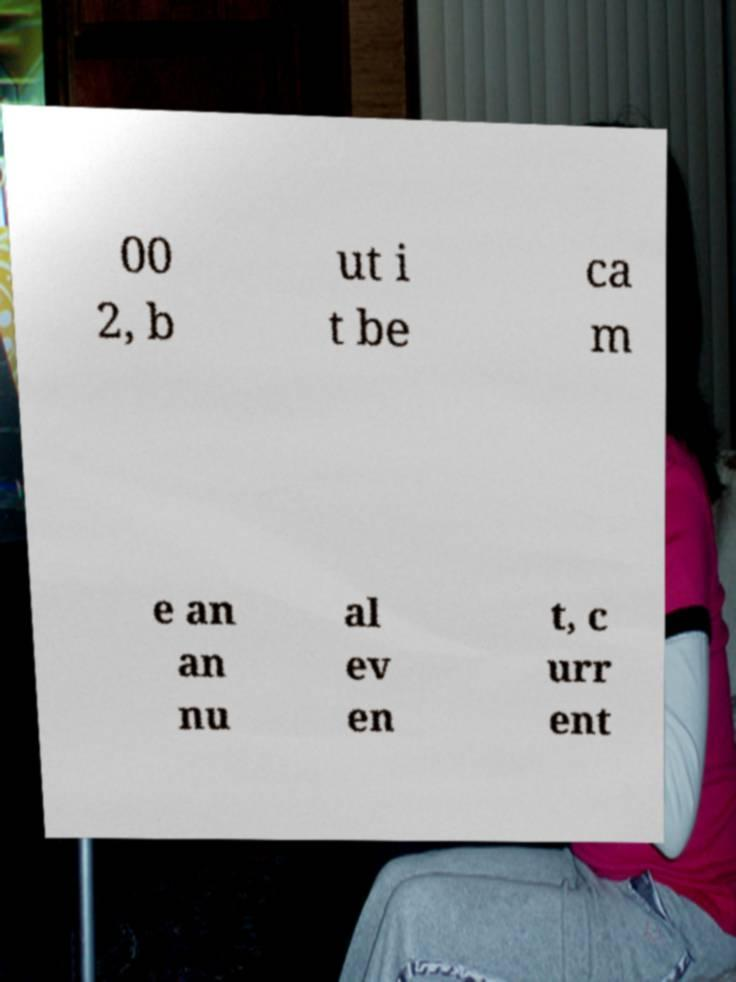What messages or text are displayed in this image? I need them in a readable, typed format. 00 2, b ut i t be ca m e an an nu al ev en t, c urr ent 